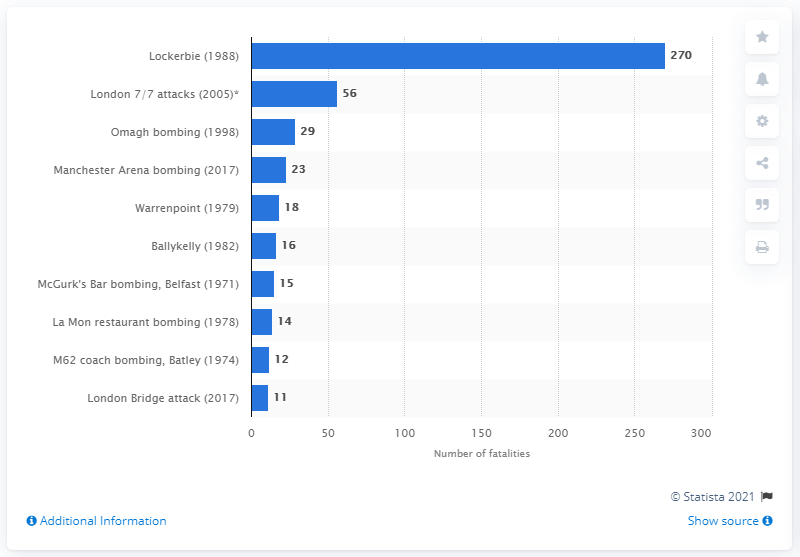Draw attention to some important aspects in this diagram. The downing of Pan Am Flight 103 resulted in the deaths of 270 people. 